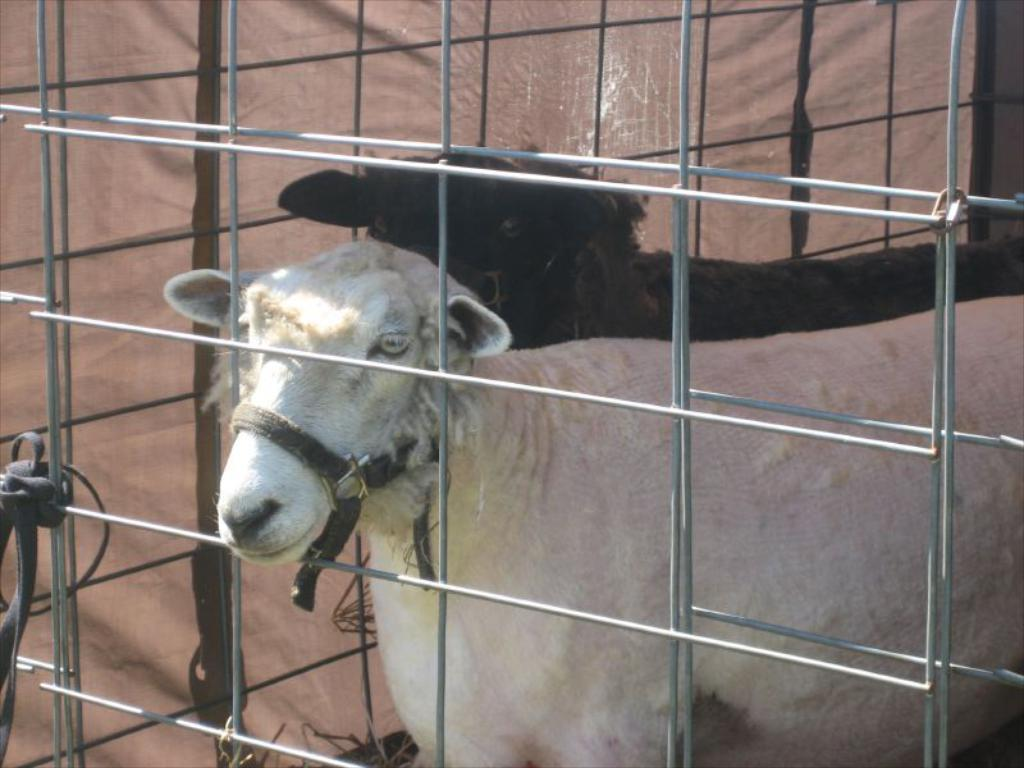How many sheep are in the image? There are two sheep in the image. What are the colors of the sheep? One sheep is white in color, and the other sheep is black in color. What is present in the image to separate the sheep from other areas? There is a metal fence in the image. What can be seen on the left side of the image? There appears to be a cloth on the left side of the image. What type of bean is growing on the black sheep in the image? There are no beans present in the image, and the sheep are not growing anything. 